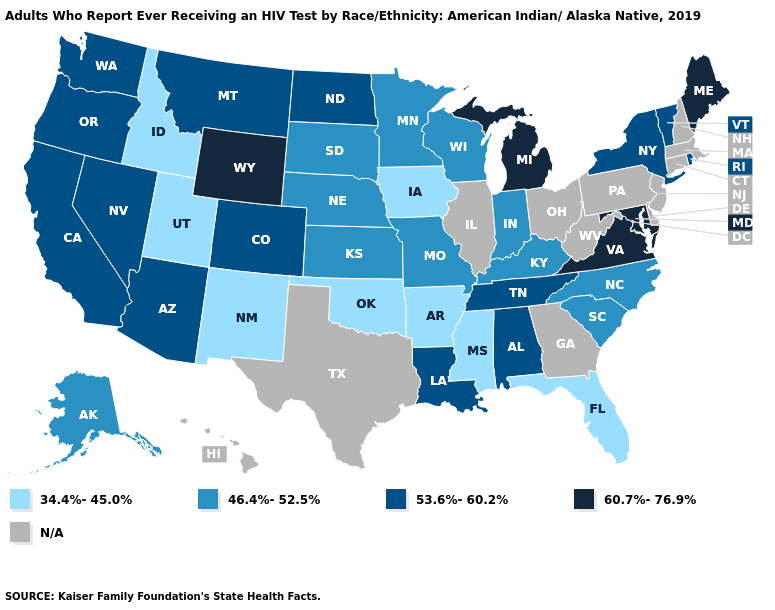What is the value of New Hampshire?
Give a very brief answer. N/A. Does Utah have the lowest value in the USA?
Concise answer only. Yes. Does Missouri have the highest value in the USA?
Quick response, please. No. What is the highest value in the USA?
Answer briefly. 60.7%-76.9%. What is the value of Louisiana?
Give a very brief answer. 53.6%-60.2%. What is the highest value in states that border Wisconsin?
Give a very brief answer. 60.7%-76.9%. What is the value of Louisiana?
Quick response, please. 53.6%-60.2%. What is the highest value in states that border Oregon?
Answer briefly. 53.6%-60.2%. What is the lowest value in the MidWest?
Write a very short answer. 34.4%-45.0%. Name the states that have a value in the range 34.4%-45.0%?
Write a very short answer. Arkansas, Florida, Idaho, Iowa, Mississippi, New Mexico, Oklahoma, Utah. Does Arizona have the highest value in the West?
Write a very short answer. No. Does Indiana have the highest value in the MidWest?
Give a very brief answer. No. 